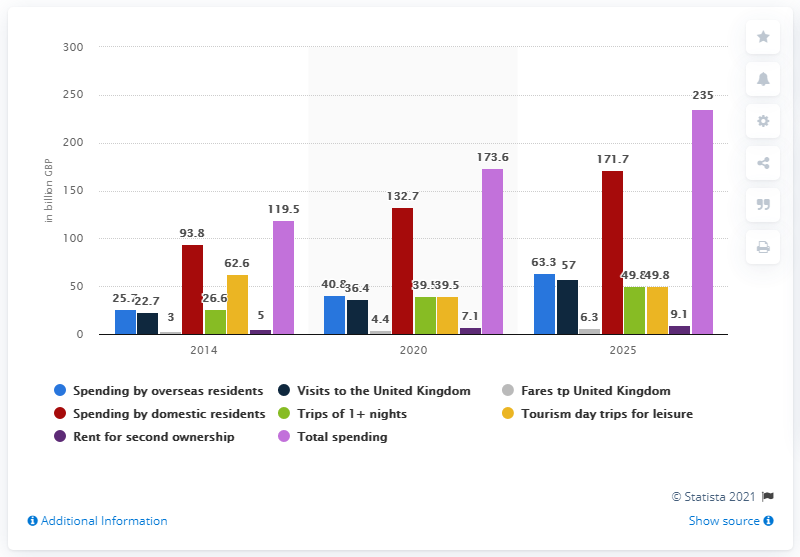How does the total spending in 2020 compare with the total forecasted spending in 2025? The total spending in the UK in 2020 stood at roughly 132.7 billion GBP. By 2025, it is forecasted to surge to 235 billion GBP, signifying an increase of more than 76%, pointing to anticipated growth in both domestic and international economic activities. 